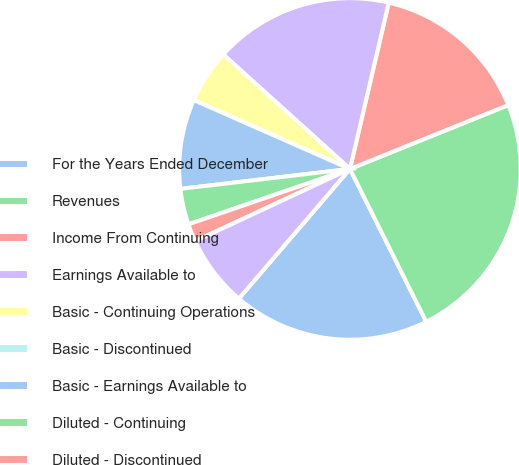<chart> <loc_0><loc_0><loc_500><loc_500><pie_chart><fcel>For the Years Ended December<fcel>Revenues<fcel>Income From Continuing<fcel>Earnings Available to<fcel>Basic - Continuing Operations<fcel>Basic - Discontinued<fcel>Basic - Earnings Available to<fcel>Diluted - Continuing<fcel>Diluted - Discontinued<fcel>Diluted - Earnings Available<nl><fcel>18.64%<fcel>23.73%<fcel>15.25%<fcel>16.95%<fcel>5.08%<fcel>0.0%<fcel>8.47%<fcel>3.39%<fcel>1.69%<fcel>6.78%<nl></chart> 